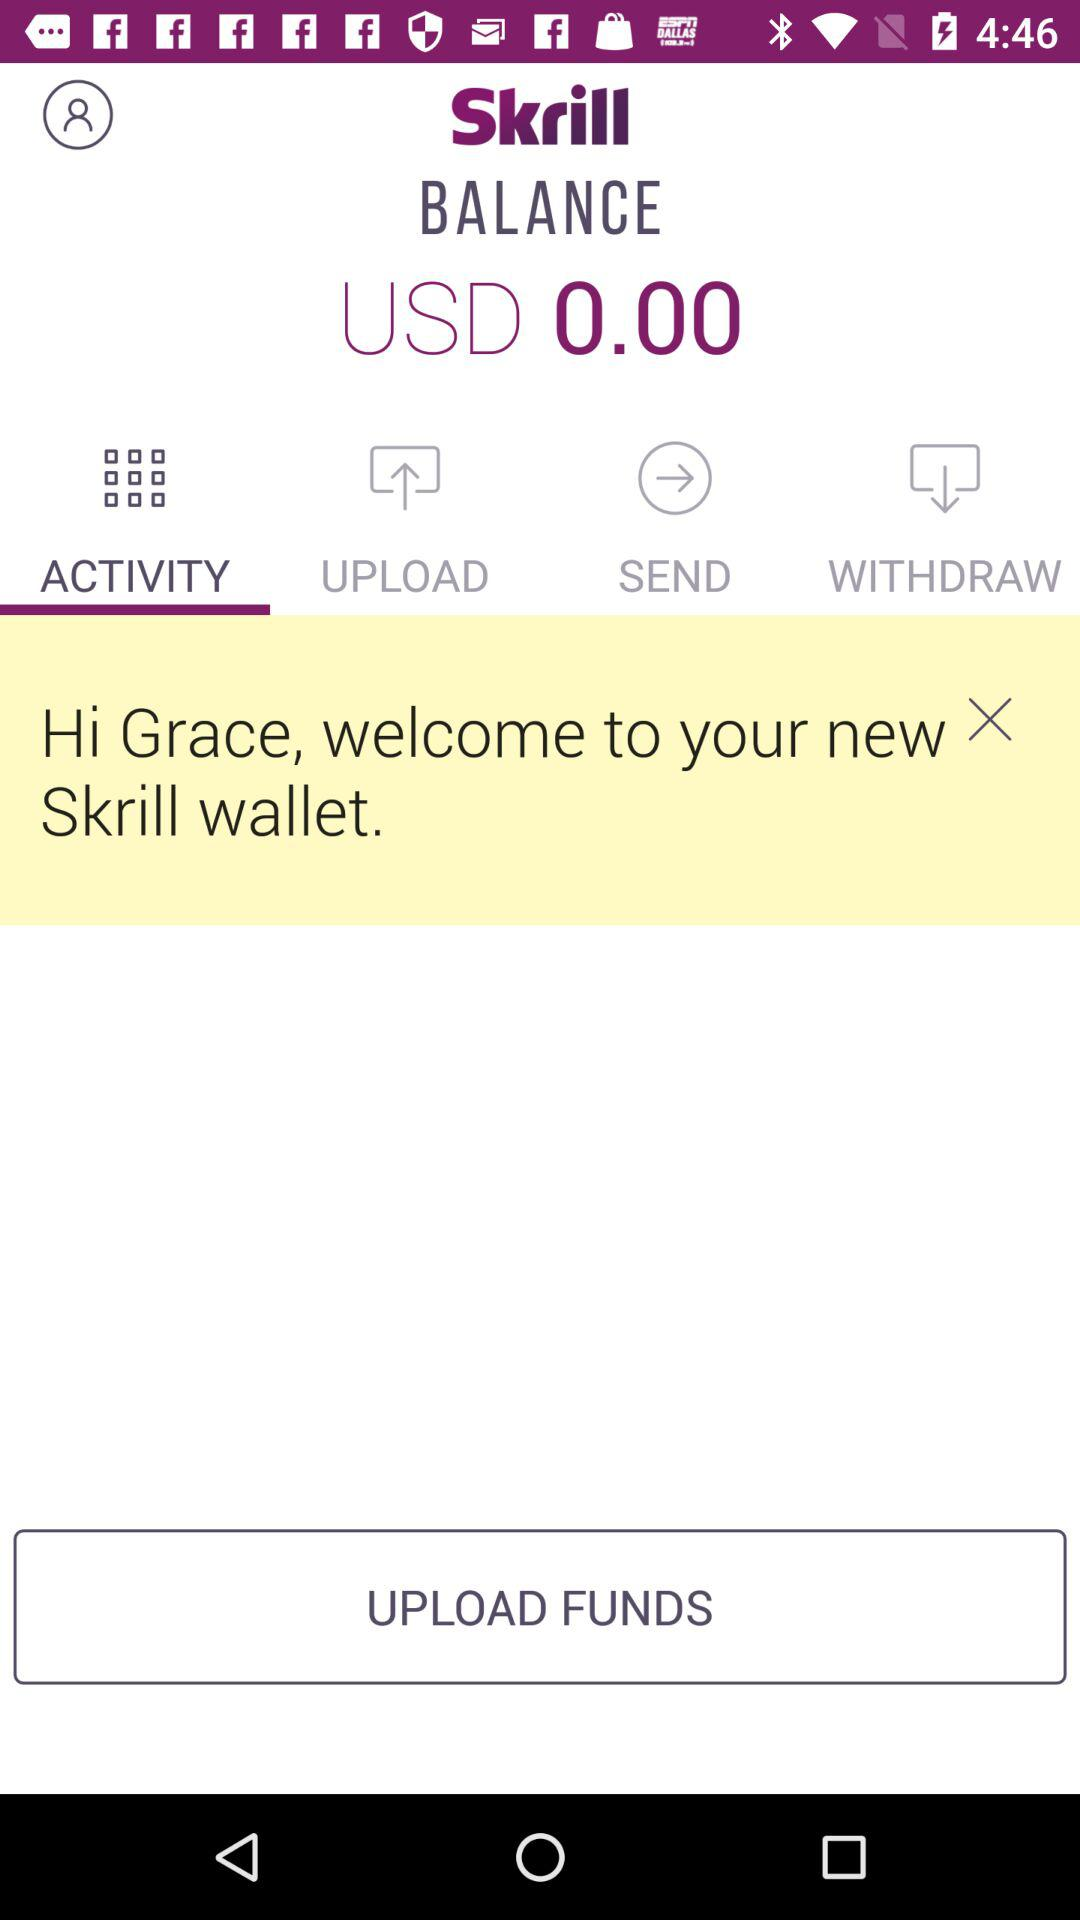What is the selected tab? The selected tab is Activity. 